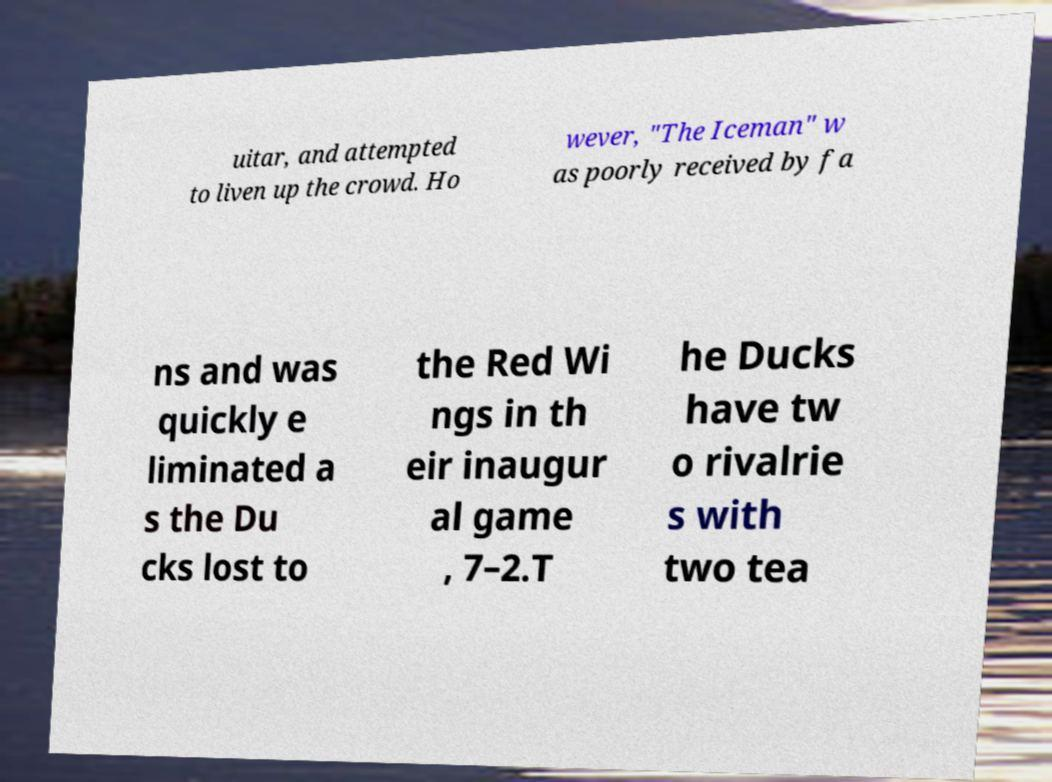Please identify and transcribe the text found in this image. uitar, and attempted to liven up the crowd. Ho wever, "The Iceman" w as poorly received by fa ns and was quickly e liminated a s the Du cks lost to the Red Wi ngs in th eir inaugur al game , 7–2.T he Ducks have tw o rivalrie s with two tea 